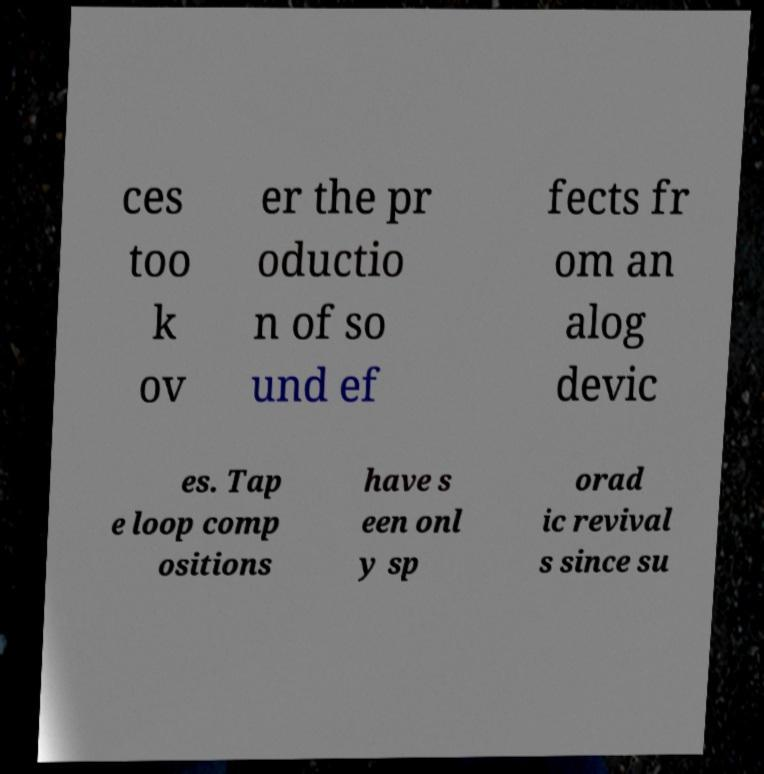For documentation purposes, I need the text within this image transcribed. Could you provide that? ces too k ov er the pr oductio n of so und ef fects fr om an alog devic es. Tap e loop comp ositions have s een onl y sp orad ic revival s since su 